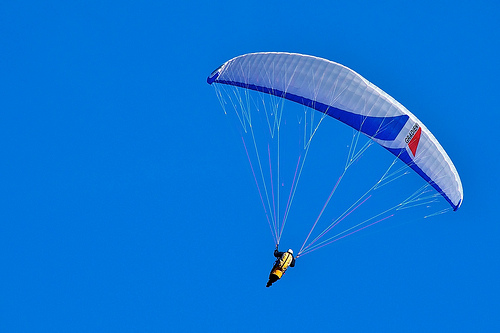Is the weather clear? Yes, the weather is clear, with a bright blue sky and no clouds in sight. 